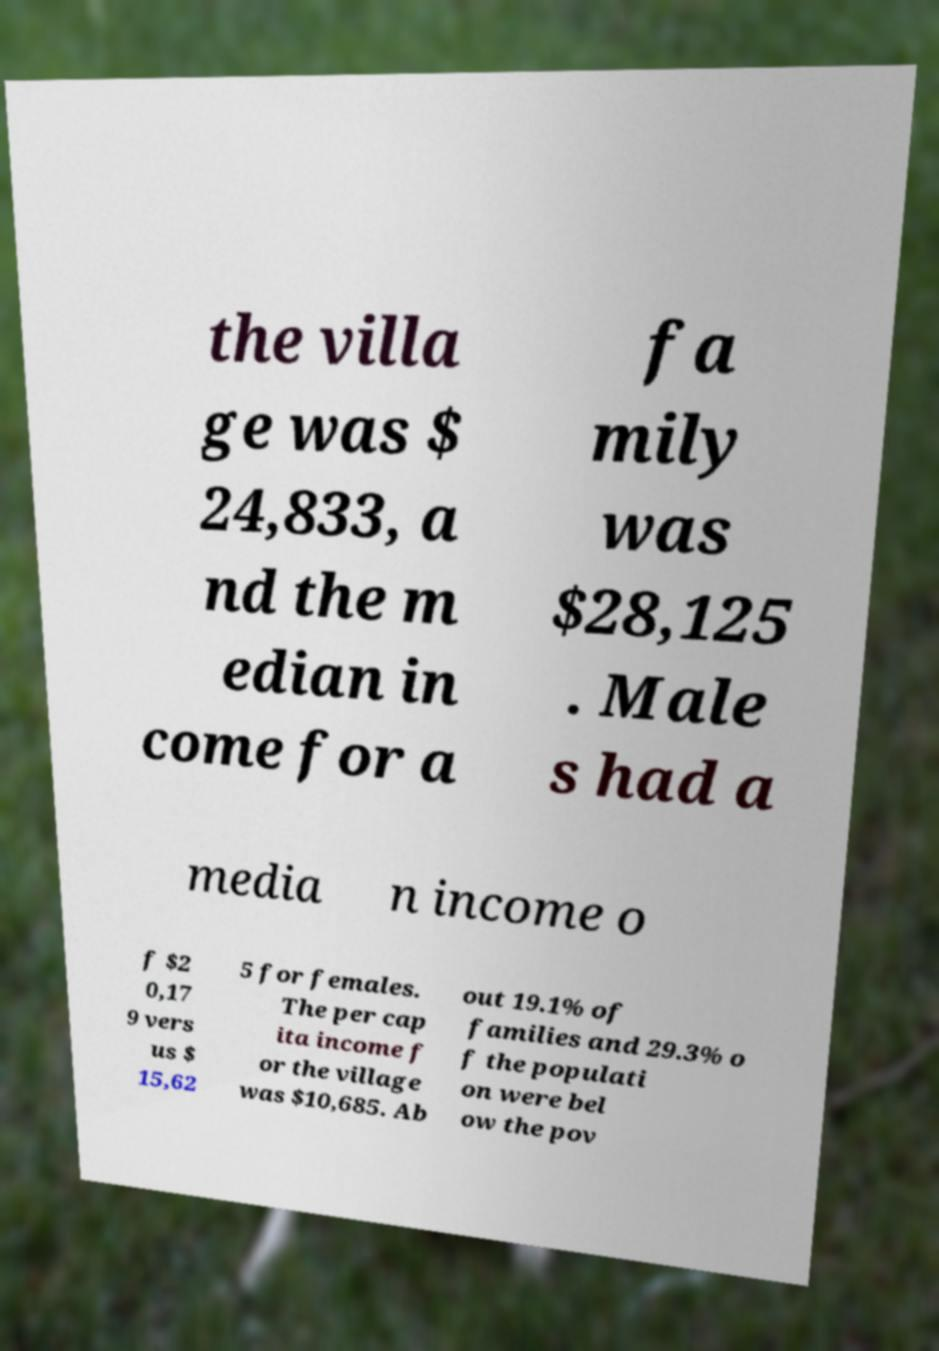I need the written content from this picture converted into text. Can you do that? the villa ge was $ 24,833, a nd the m edian in come for a fa mily was $28,125 . Male s had a media n income o f $2 0,17 9 vers us $ 15,62 5 for females. The per cap ita income f or the village was $10,685. Ab out 19.1% of families and 29.3% o f the populati on were bel ow the pov 